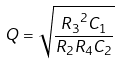Convert formula to latex. <formula><loc_0><loc_0><loc_500><loc_500>Q = \sqrt { \frac { { R _ { 3 } } ^ { 2 } C _ { 1 } } { R _ { 2 } R _ { 4 } C _ { 2 } } }</formula> 